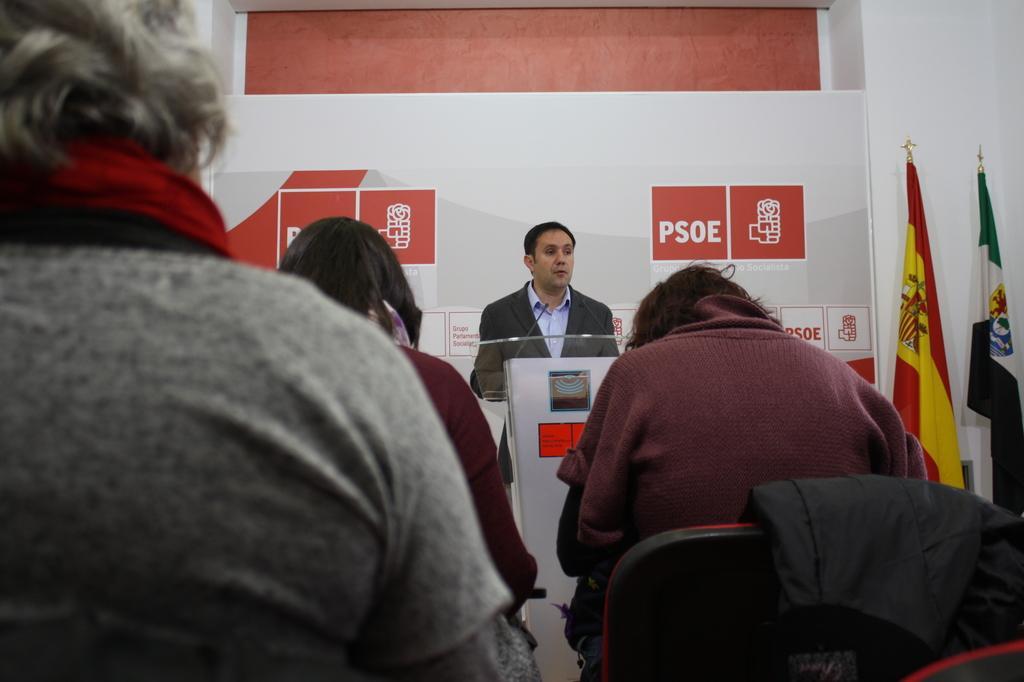In one or two sentences, can you explain what this image depicts? On the left side, there are two persons sitting. On the right side, there is a person sitting on a chair, on which there is a cloth. In the background, there is a person in a suit, standing and speaking in front of a mic which is attached to a stand, there are two flags and a banner attached to a white wall. 